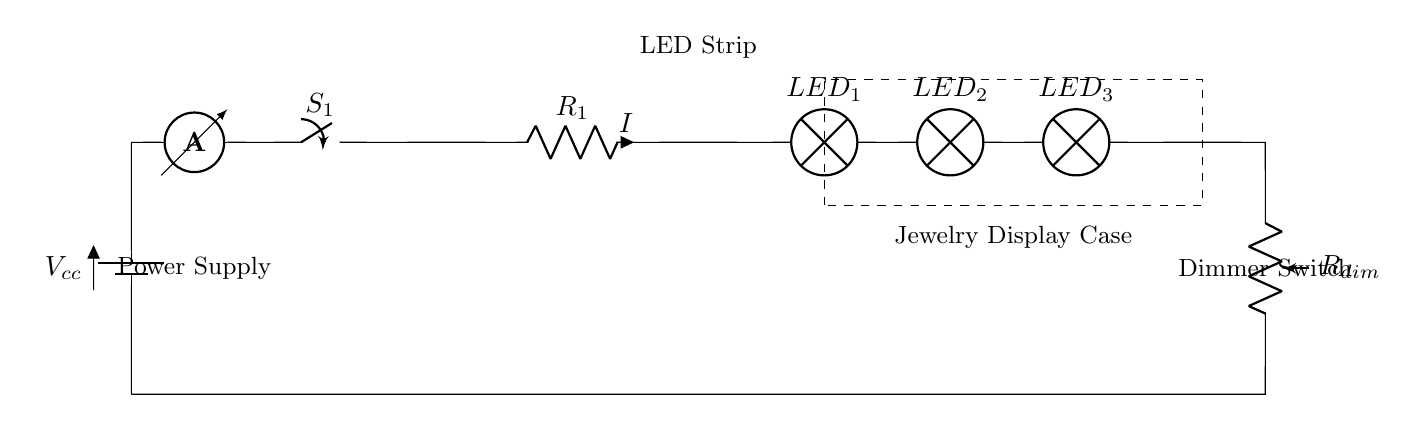What is the power supply type in this circuit? The power supply is a battery, as indicated by the symbol used to represent it (battery1).
Answer: Battery How many LED strips are present in the circuit? There are three LED lamps labeled LED_1, LED_2, and LED_3 that represent the LED strips.
Answer: Three What component is used to adjust the brightness of the LEDs? A potentiometer is used as the dimmer switch, which is depicted in the diagram showing the resistance variable for brightness control.
Answer: Potentiometer What is the role of the switch in this circuit? The switch (S_1) is used to turn the circuit on or off, controlling the flow of current through the circuit.
Answer: On/Off What is the current designation in the circuit? The current is denoted by the letter "I" which is placed next to resistor R_1, indicating the current flow through this part of the circuit.
Answer: I How is the dimmer switch connected in relation to the LEDs? The dimmer switch is connected in series after the LEDs, meaning the current flows through the LEDs before reaching the dimmer.
Answer: In series 